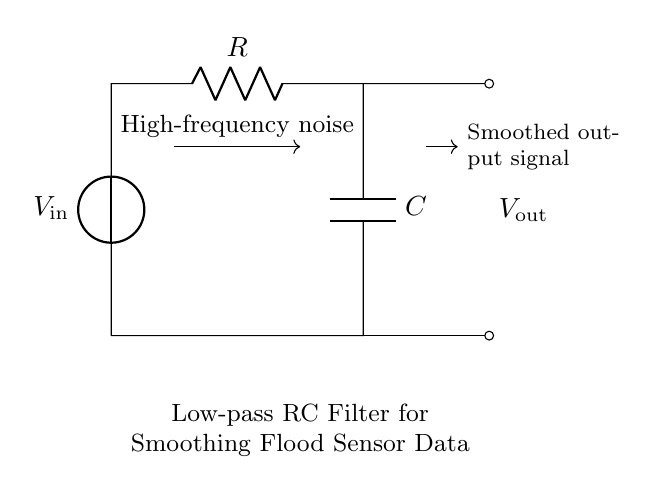What components are present in this circuit? The circuit includes a voltage source, a resistor, and a capacitor. These are indicated by the labels in the diagram.
Answer: voltage source, resistor, capacitor What does the output voltage represent? The output voltage represents the smoothed signal after passing through the low-pass filter circuit, which reduces high-frequency noise.
Answer: smoothed output signal What effect does the resistor have on the circuit? The resistor limits the current flowing through the circuit, impacting the charging and discharging rates of the capacitor, thus influencing the time constant of the filter.
Answer: limits current What is the main purpose of this low-pass RC filter? The main purpose is to smooth the flood sensor data by allowing low-frequency signals to pass while attenuating high-frequency noise, providing a clearer representation of the sensor readings.
Answer: smoothing flood sensor data What happens to high-frequency noise in this circuit? The high-frequency noise is attenuated, meaning it is reduced in amplitude as it passes through the circuit, leading to a cleaner output signal.
Answer: attenuated What is the effect of increasing the resistance in this RC circuit? Increasing the resistance will increase the time constant of the circuit, leading to slower charging and discharging of the capacitor, which affects the responsiveness of the filter to changes in the input signal.
Answer: slower response 